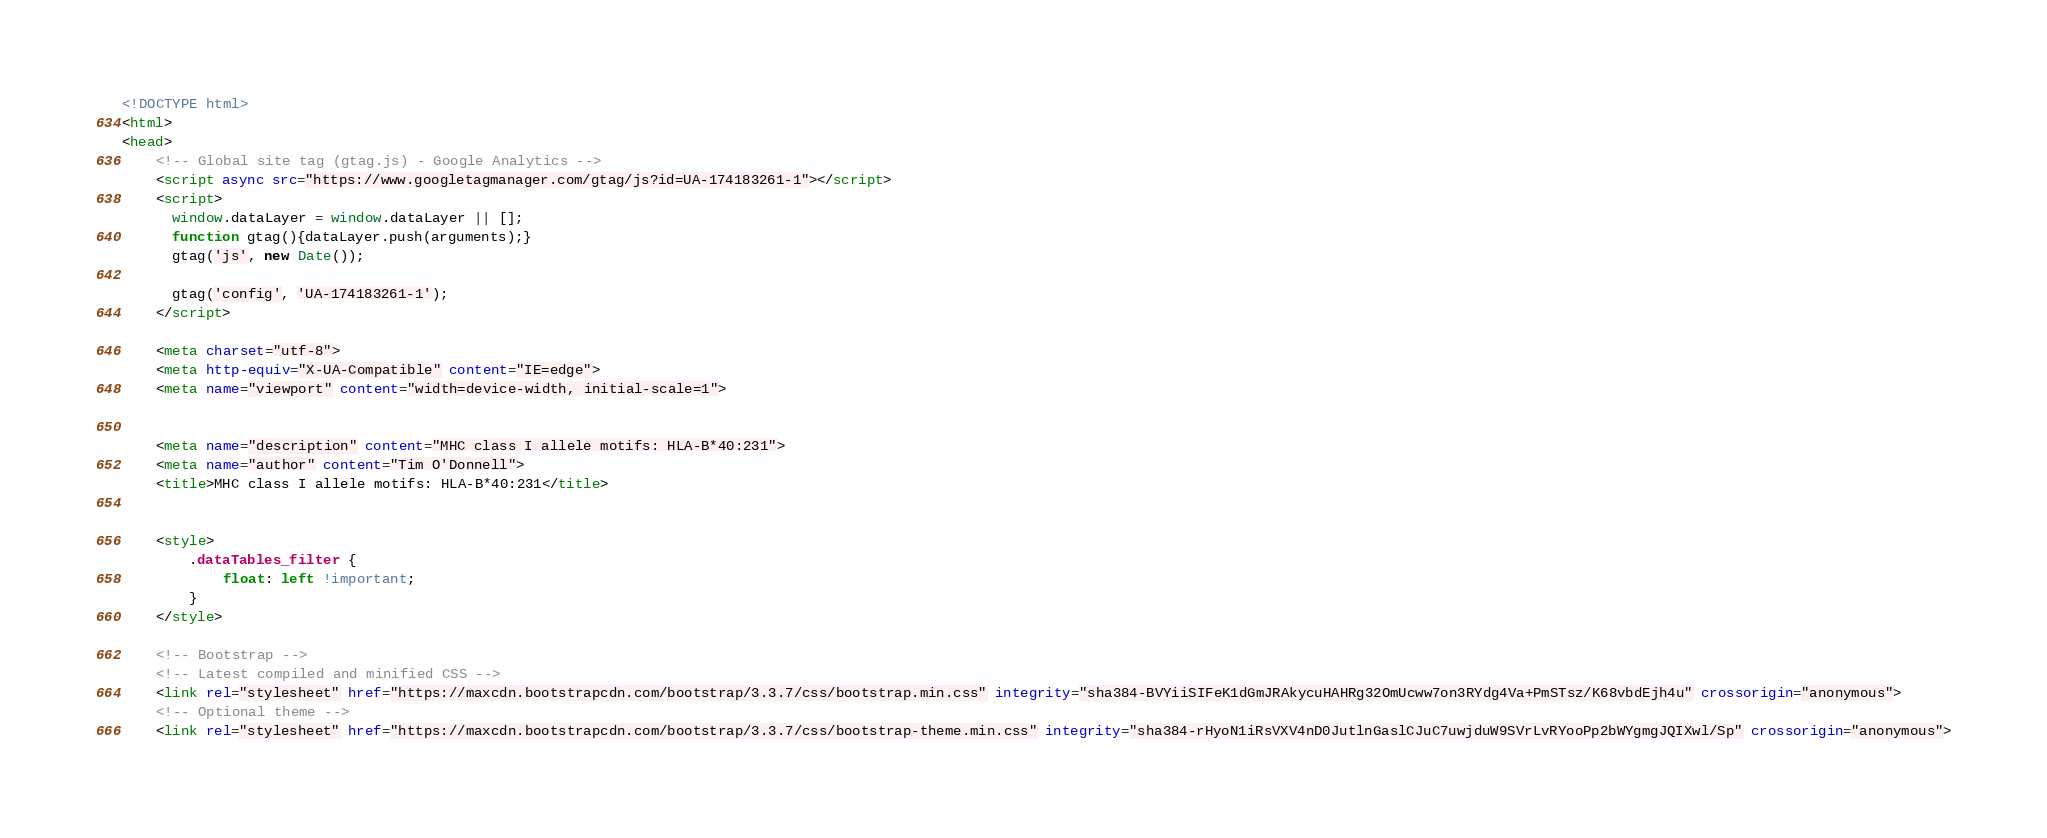Convert code to text. <code><loc_0><loc_0><loc_500><loc_500><_HTML_><!DOCTYPE html>
<html>
<head>
    <!-- Global site tag (gtag.js) - Google Analytics -->
    <script async src="https://www.googletagmanager.com/gtag/js?id=UA-174183261-1"></script>
    <script>
      window.dataLayer = window.dataLayer || [];
      function gtag(){dataLayer.push(arguments);}
      gtag('js', new Date());

      gtag('config', 'UA-174183261-1');
    </script>

    <meta charset="utf-8">
    <meta http-equiv="X-UA-Compatible" content="IE=edge">
    <meta name="viewport" content="width=device-width, initial-scale=1">

    
    <meta name="description" content="MHC class I allele motifs: HLA-B*40:231">
    <meta name="author" content="Tim O'Donnell">
    <title>MHC class I allele motifs: HLA-B*40:231</title>
    

    <style>
        .dataTables_filter {
            float: left !important;
        }
    </style>

    <!-- Bootstrap -->
    <!-- Latest compiled and minified CSS -->
    <link rel="stylesheet" href="https://maxcdn.bootstrapcdn.com/bootstrap/3.3.7/css/bootstrap.min.css" integrity="sha384-BVYiiSIFeK1dGmJRAkycuHAHRg32OmUcww7on3RYdg4Va+PmSTsz/K68vbdEjh4u" crossorigin="anonymous">
    <!-- Optional theme -->
    <link rel="stylesheet" href="https://maxcdn.bootstrapcdn.com/bootstrap/3.3.7/css/bootstrap-theme.min.css" integrity="sha384-rHyoN1iRsVXV4nD0JutlnGaslCJuC7uwjduW9SVrLvRYooPp2bWYgmgJQIXwl/Sp" crossorigin="anonymous">
</code> 